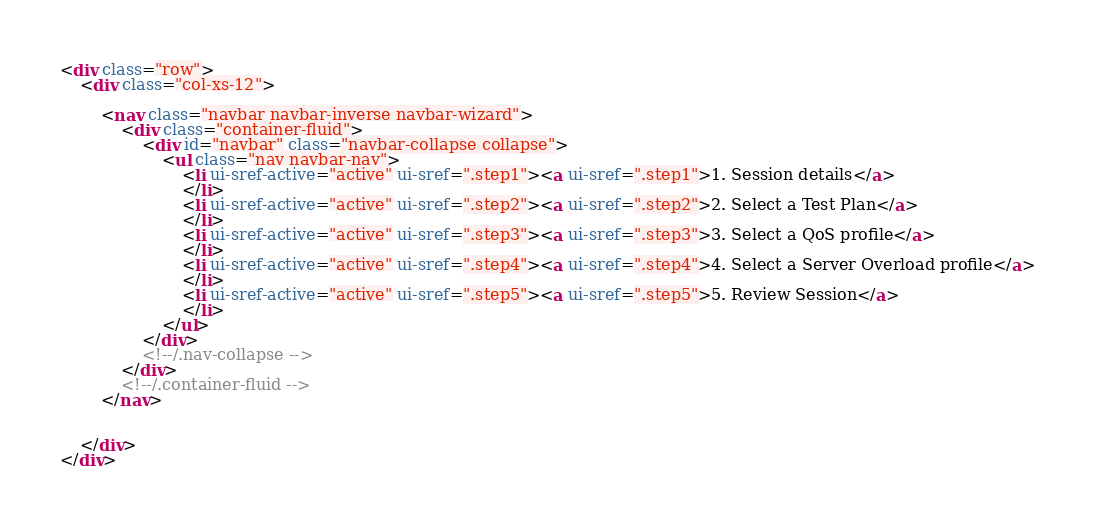Convert code to text. <code><loc_0><loc_0><loc_500><loc_500><_HTML_><div class="row">
    <div class="col-xs-12">

        <nav class="navbar navbar-inverse navbar-wizard">
            <div class="container-fluid">
                <div id="navbar" class="navbar-collapse collapse">
                    <ul class="nav navbar-nav">
                        <li ui-sref-active="active" ui-sref=".step1"><a ui-sref=".step1">1. Session details</a>
                        </li>
                        <li ui-sref-active="active" ui-sref=".step2"><a ui-sref=".step2">2. Select a Test Plan</a>
                        </li>
                        <li ui-sref-active="active" ui-sref=".step3"><a ui-sref=".step3">3. Select a QoS profile</a>
                        </li>
                        <li ui-sref-active="active" ui-sref=".step4"><a ui-sref=".step4">4. Select a Server Overload profile</a>
                        </li>
                        <li ui-sref-active="active" ui-sref=".step5"><a ui-sref=".step5">5. Review Session</a>
                        </li>
                    </ul>
                </div>
                <!--/.nav-collapse -->
            </div>
            <!--/.container-fluid -->
        </nav>


    </div>
</div>

</code> 